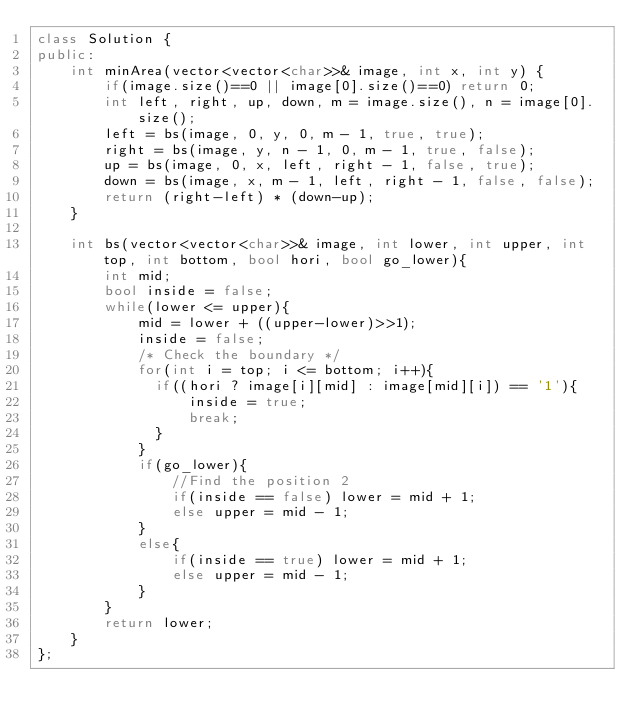<code> <loc_0><loc_0><loc_500><loc_500><_C++_>class Solution {
public:
    int minArea(vector<vector<char>>& image, int x, int y) {
        if(image.size()==0 || image[0].size()==0) return 0;
        int left, right, up, down, m = image.size(), n = image[0].size();
        left = bs(image, 0, y, 0, m - 1, true, true);
        right = bs(image, y, n - 1, 0, m - 1, true, false);
        up = bs(image, 0, x, left, right - 1, false, true);
        down = bs(image, x, m - 1, left, right - 1, false, false);
        return (right-left) * (down-up);
    }
    
    int bs(vector<vector<char>>& image, int lower, int upper, int top, int bottom, bool hori, bool go_lower){
        int mid;
        bool inside = false;
        while(lower <= upper){
            mid = lower + ((upper-lower)>>1);
            inside = false;
            /* Check the boundary */
            for(int i = top; i <= bottom; i++){
              if((hori ? image[i][mid] : image[mid][i]) == '1'){
                  inside = true;
                  break;
              }
            }
            if(go_lower){
                //Find the position 2
                if(inside == false) lower = mid + 1;
                else upper = mid - 1;
            }
            else{
                if(inside == true) lower = mid + 1;
                else upper = mid - 1;
            }
        }
        return lower;
    }
};</code> 